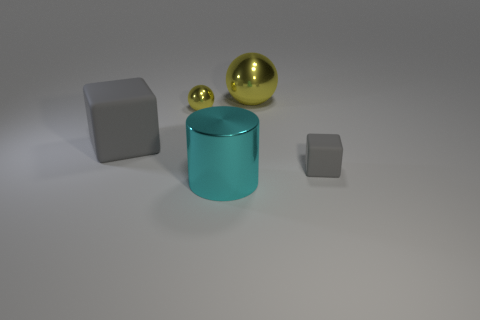Add 1 blue matte cubes. How many objects exist? 6 Subtract all cylinders. How many objects are left? 4 Subtract 2 blocks. How many blocks are left? 0 Subtract all purple cylinders. Subtract all cyan spheres. How many cylinders are left? 1 Subtract all big purple matte cylinders. Subtract all large objects. How many objects are left? 2 Add 2 tiny spheres. How many tiny spheres are left? 3 Add 2 blocks. How many blocks exist? 4 Subtract 0 green spheres. How many objects are left? 5 